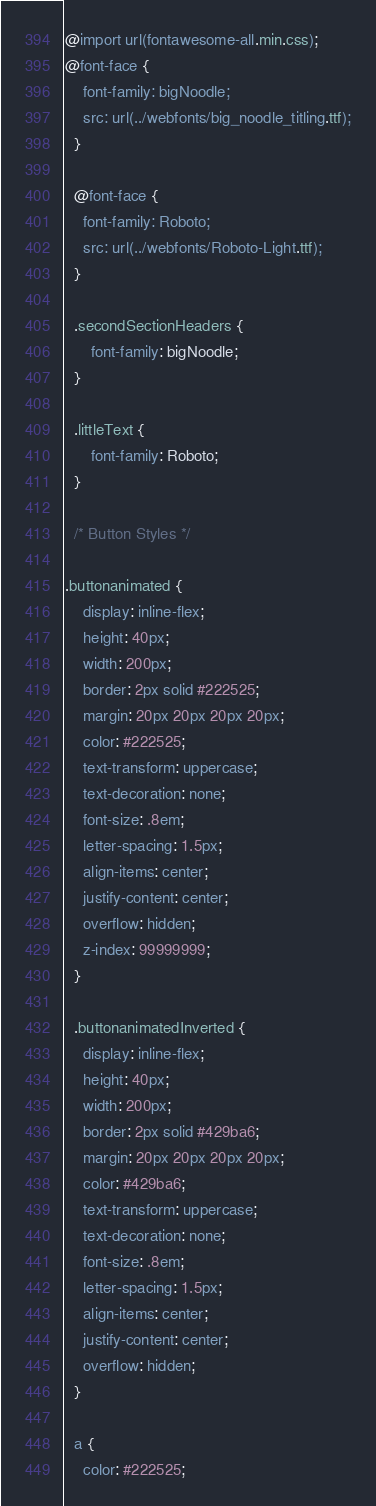<code> <loc_0><loc_0><loc_500><loc_500><_CSS_>@import url(fontawesome-all.min.css);
@font-face {
	font-family: bigNoodle;
	src: url(../webfonts/big_noodle_titling.ttf);
  }

  @font-face {
	font-family: Roboto;
	src: url(../webfonts/Roboto-Light.ttf);
  }

  .secondSectionHeaders {
	  font-family: bigNoodle;
  }

  .littleText {
	  font-family: Roboto;
  }

  /* Button Styles */

.buttonanimated {
	display: inline-flex;
	height: 40px;
	width: 200px;
	border: 2px solid #222525;
	margin: 20px 20px 20px 20px;
	color: #222525;
	text-transform: uppercase;
	text-decoration: none;
	font-size: .8em;
	letter-spacing: 1.5px;
	align-items: center;
	justify-content: center;
	overflow: hidden;
	z-index: 99999999;
  }

  .buttonanimatedInverted {
	display: inline-flex;
	height: 40px;
	width: 200px;
	border: 2px solid #429ba6;
	margin: 20px 20px 20px 20px;
	color: #429ba6;
	text-transform: uppercase;
	text-decoration: none;
	font-size: .8em;
	letter-spacing: 1.5px;
	align-items: center;
	justify-content: center;
	overflow: hidden;
  }
  
  a {
	color: #222525;</code> 